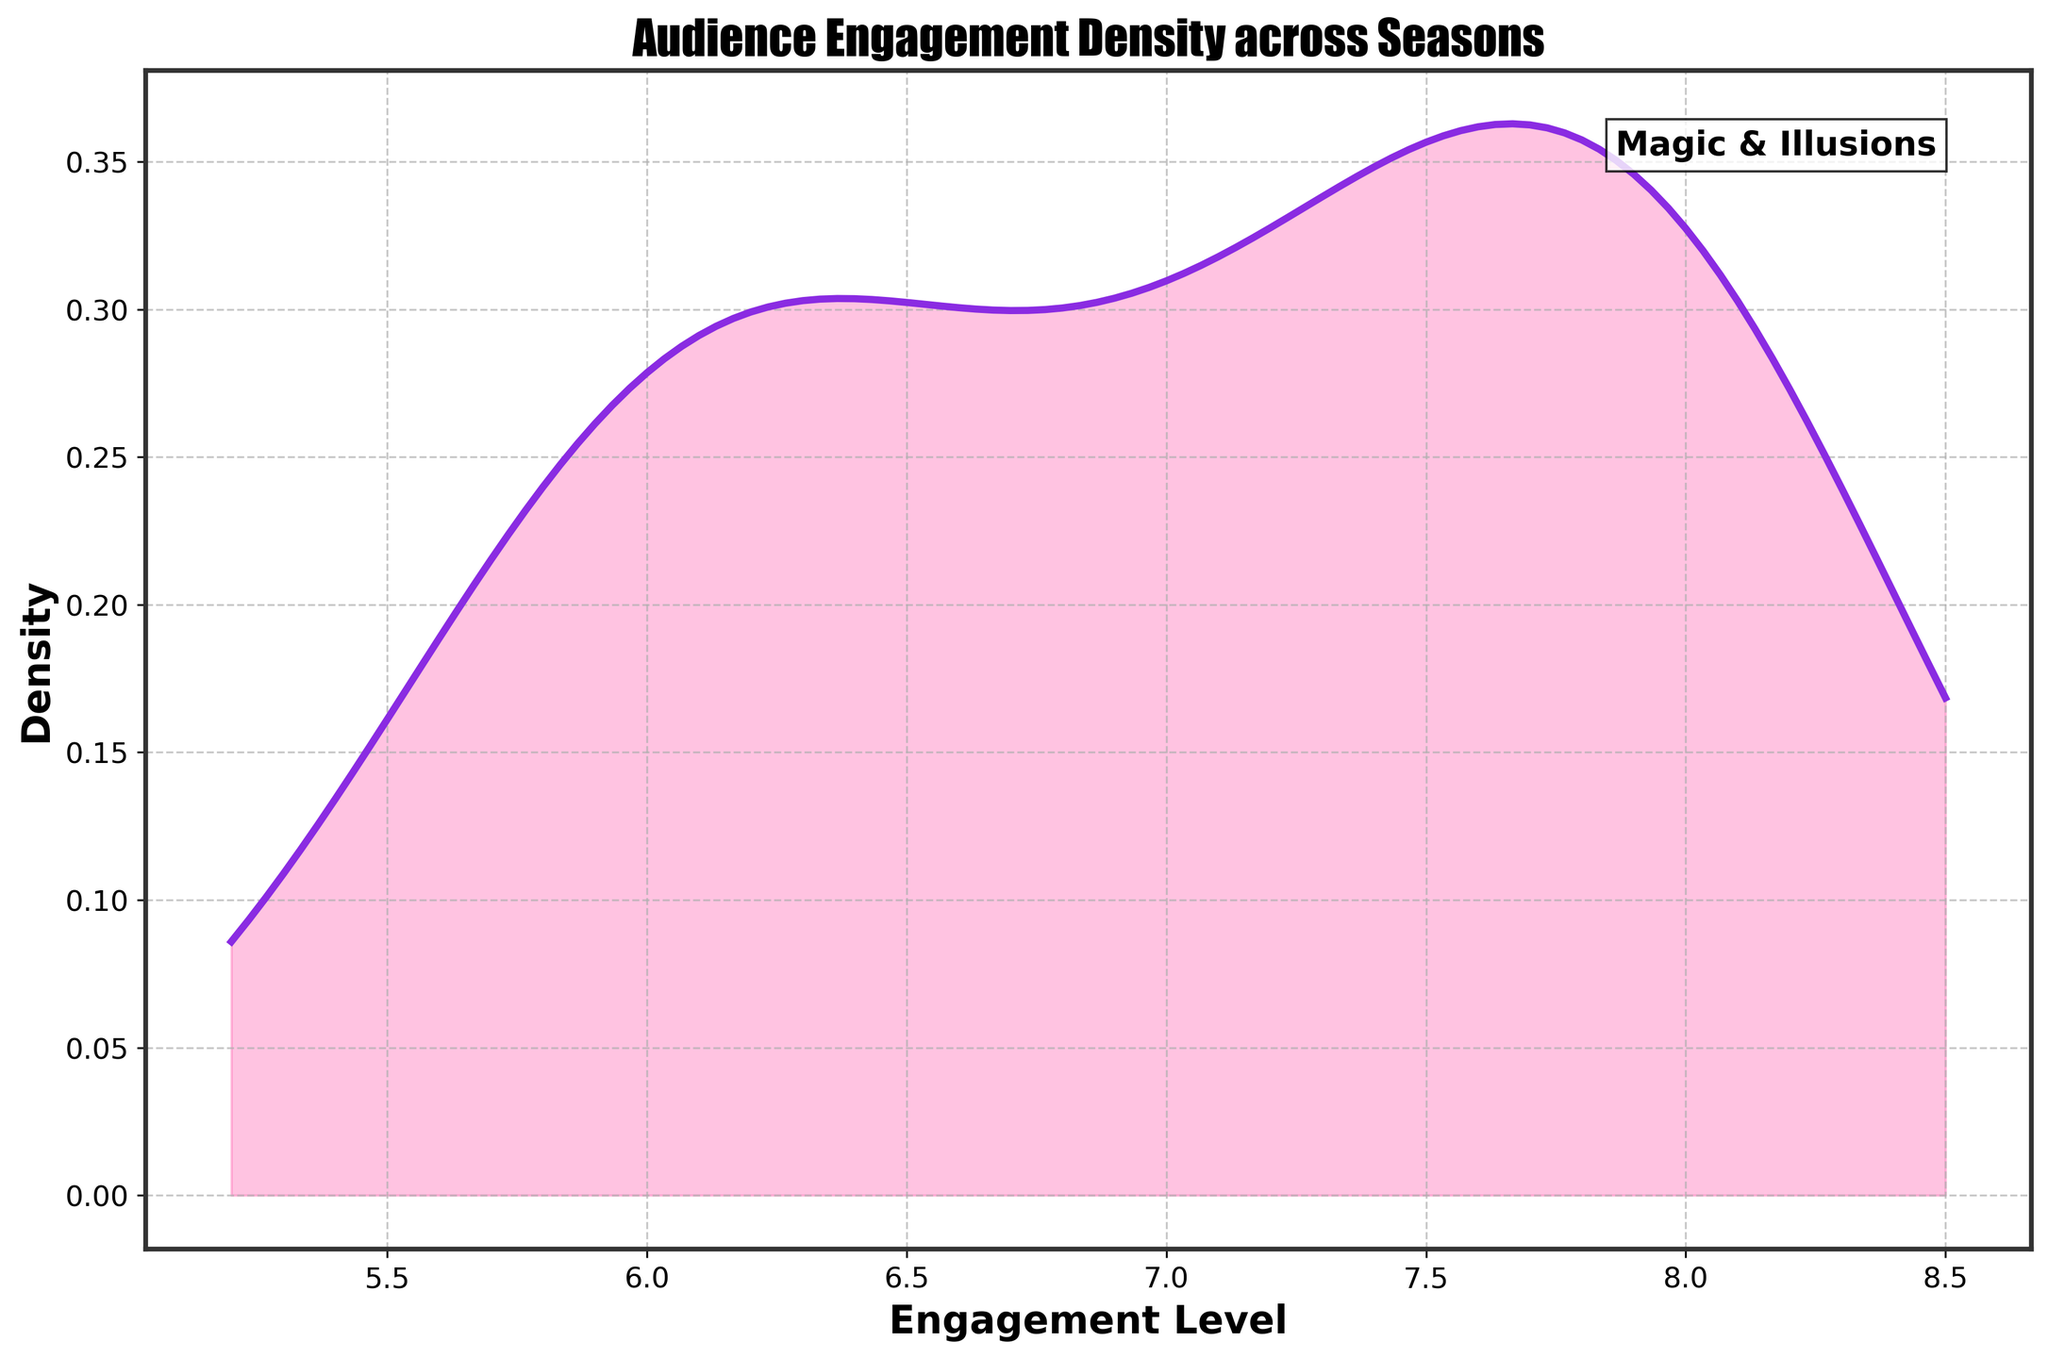What's the main title of the plot? The title is usually located at the top of the plot, prominently displayed to describe the content. In this case, I refer to the visible information in the figure.
Answer: Audience Engagement Density across Seasons What are the labels for the x-axis and y-axis? By looking at the figure, you can see the text that describes the x-axis and y-axis, which indicates what these axes represent.
Answer: X-axis: Engagement Level, Y-axis: Density What does the density plot's overall shape suggest about the engagement levels over the seasons? Observing the density plot's overall shape allows us to infer peaks and spread in engagement levels. Here, you can see a single peak and the spread of the distribution.
Answer: The shape suggests a single peak with a spread slightly towards higher engagement levels Which range of engagement levels has the highest density? Looking at where the plot reaches its highest point on the y-axis helps identify the range of engagement levels where density is the highest.
Answer: Approximately between 7.5 and 8.0 Does the engagement level ever increase to more than 8.5? This can be determined by checking the x-axis range shown on the density plot to see if it extends beyond 8.5 and if the density contributes or drops off before this range.
Answer: No, it doesn't exceed 8.5 How does the density plot indicate the engagement level trends over multiple seasons? Observing the plot's density distribution helps understand trends, where a concentration of density around certain engagement levels indicates the typical engagement level changes over seasons.
Answer: Trends towards higher engagement levels over multiple seasons By looking at the colored area under the density curve, what can you infer about audience engagement spread? The colored area under the curve shows how engagement levels are distributed. A wider spread suggests variability, while a narrow spread indicates consistency.
Answer: The spread shows increasing engagement levels with some variability How does the axis customization and style, such as grid lines and tick marks, affect the readability of the plot? Examining elements like grids and tick marks, which enhance clarity and readability by providing reference points and separating data visually.
Answer: They improve readability by providing reference and enhancing the plot details 